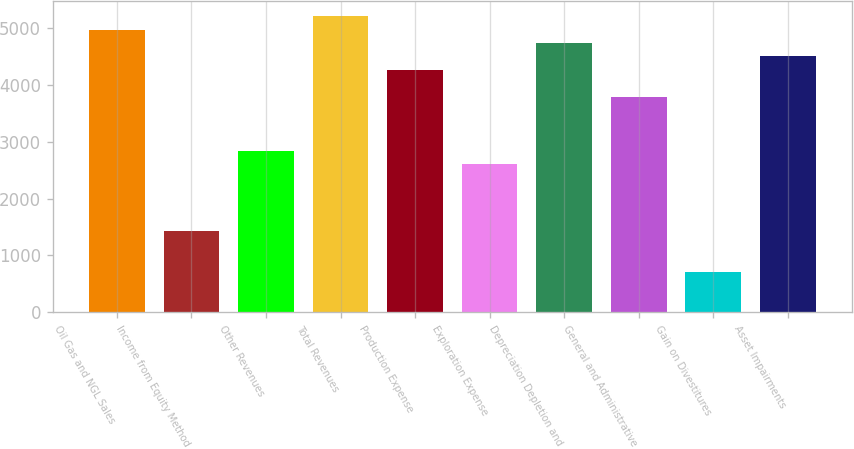Convert chart. <chart><loc_0><loc_0><loc_500><loc_500><bar_chart><fcel>Oil Gas and NGL Sales<fcel>Income from Equity Method<fcel>Other Revenues<fcel>Total Revenues<fcel>Production Expense<fcel>Exploration Expense<fcel>Depreciation Depletion and<fcel>General and Administrative<fcel>Gain on Divestitures<fcel>Asset Impairments<nl><fcel>4978.28<fcel>1422.92<fcel>2845.1<fcel>5215.3<fcel>4267.22<fcel>2608.07<fcel>4741.26<fcel>3793.18<fcel>711.84<fcel>4504.24<nl></chart> 